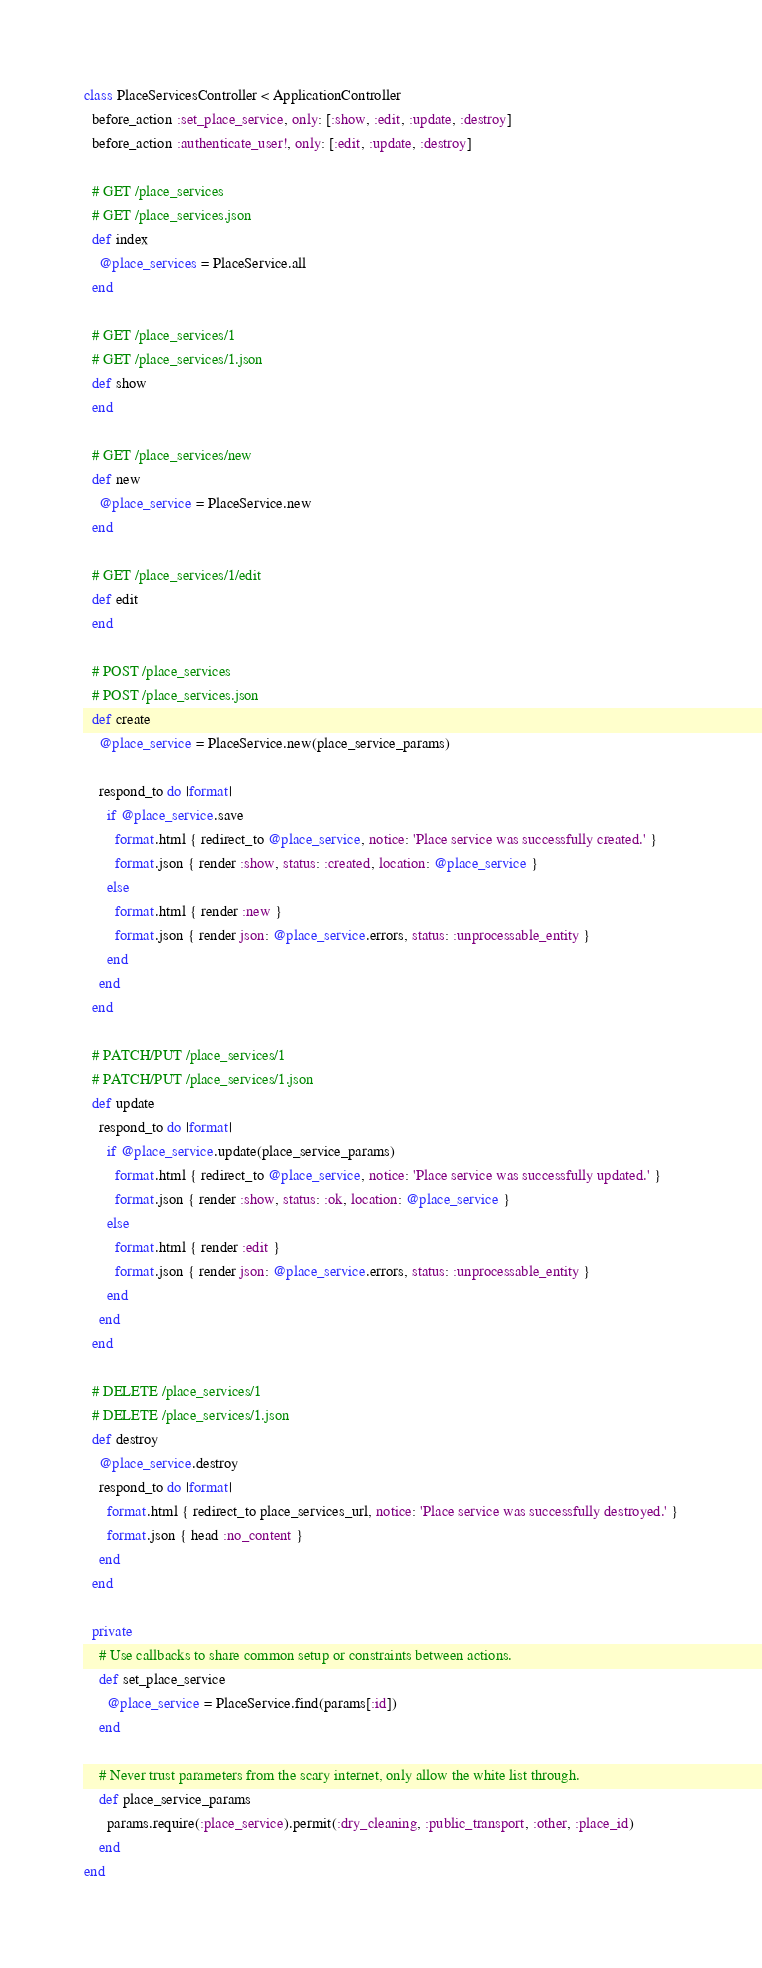<code> <loc_0><loc_0><loc_500><loc_500><_Ruby_>class PlaceServicesController < ApplicationController
  before_action :set_place_service, only: [:show, :edit, :update, :destroy]
  before_action :authenticate_user!, only: [:edit, :update, :destroy]

  # GET /place_services
  # GET /place_services.json
  def index
    @place_services = PlaceService.all
  end

  # GET /place_services/1
  # GET /place_services/1.json
  def show
  end

  # GET /place_services/new
  def new
    @place_service = PlaceService.new
  end

  # GET /place_services/1/edit
  def edit
  end

  # POST /place_services
  # POST /place_services.json
  def create
    @place_service = PlaceService.new(place_service_params)

    respond_to do |format|
      if @place_service.save
        format.html { redirect_to @place_service, notice: 'Place service was successfully created.' }
        format.json { render :show, status: :created, location: @place_service }
      else
        format.html { render :new }
        format.json { render json: @place_service.errors, status: :unprocessable_entity }
      end
    end
  end

  # PATCH/PUT /place_services/1
  # PATCH/PUT /place_services/1.json
  def update
    respond_to do |format|
      if @place_service.update(place_service_params)
        format.html { redirect_to @place_service, notice: 'Place service was successfully updated.' }
        format.json { render :show, status: :ok, location: @place_service }
      else
        format.html { render :edit }
        format.json { render json: @place_service.errors, status: :unprocessable_entity }
      end
    end
  end

  # DELETE /place_services/1
  # DELETE /place_services/1.json
  def destroy
    @place_service.destroy
    respond_to do |format|
      format.html { redirect_to place_services_url, notice: 'Place service was successfully destroyed.' }
      format.json { head :no_content }
    end
  end

  private
    # Use callbacks to share common setup or constraints between actions.
    def set_place_service
      @place_service = PlaceService.find(params[:id])
    end

    # Never trust parameters from the scary internet, only allow the white list through.
    def place_service_params
      params.require(:place_service).permit(:dry_cleaning, :public_transport, :other, :place_id)
    end
end
</code> 